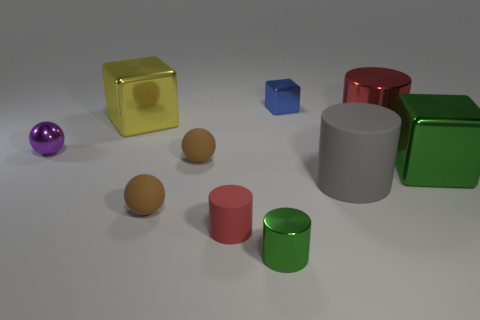Does the red cylinder on the right side of the blue thing have the same material as the gray cylinder?
Make the answer very short. No. How many other objects are there of the same material as the large gray thing?
Make the answer very short. 3. What number of things are either cubes to the left of the green metal cube or metal objects right of the small red thing?
Give a very brief answer. 5. There is a small object that is on the right side of the green metallic cylinder; does it have the same shape as the large metal thing on the left side of the red rubber thing?
Provide a short and direct response. Yes. The green metal object that is the same size as the yellow metallic cube is what shape?
Provide a short and direct response. Cube. How many shiny things are either red things or small cubes?
Offer a terse response. 2. Is the big block to the left of the blue shiny object made of the same material as the small brown object that is in front of the large gray cylinder?
Your answer should be compact. No. What is the color of the tiny cube that is the same material as the big green thing?
Make the answer very short. Blue. Are there more large shiny things that are right of the tiny green metallic object than purple metal objects right of the yellow metal object?
Make the answer very short. Yes. Is there a large brown ball?
Make the answer very short. No. 